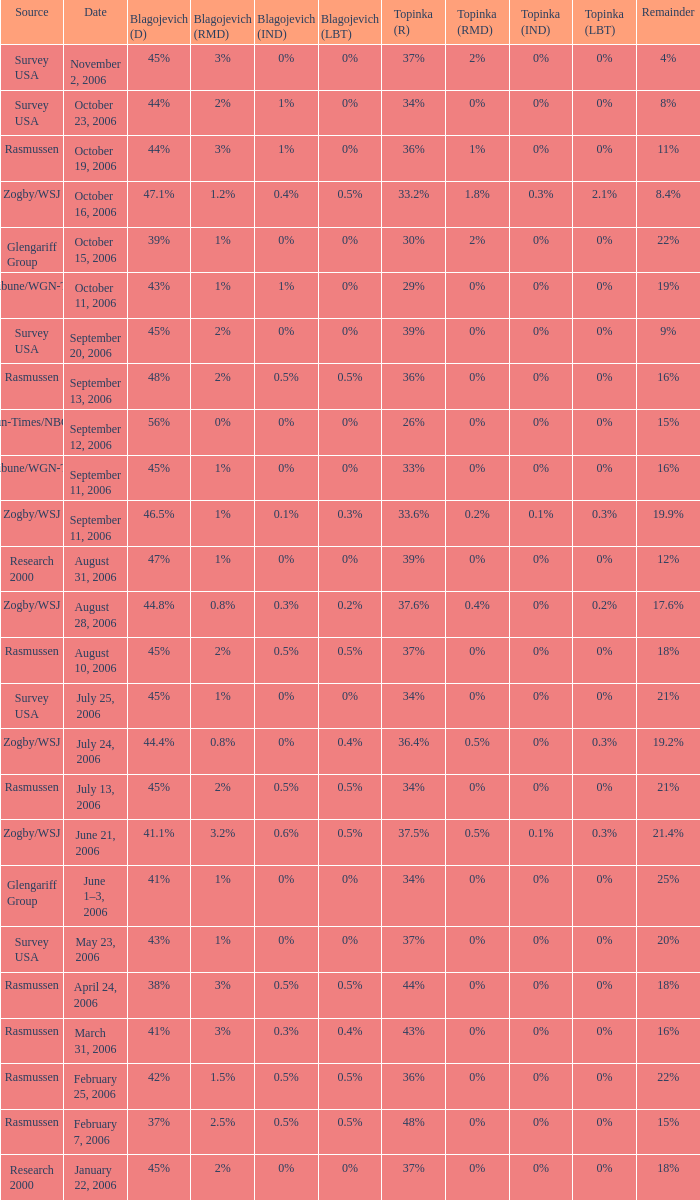Which Topinka happened on january 22, 2006? 37%. 